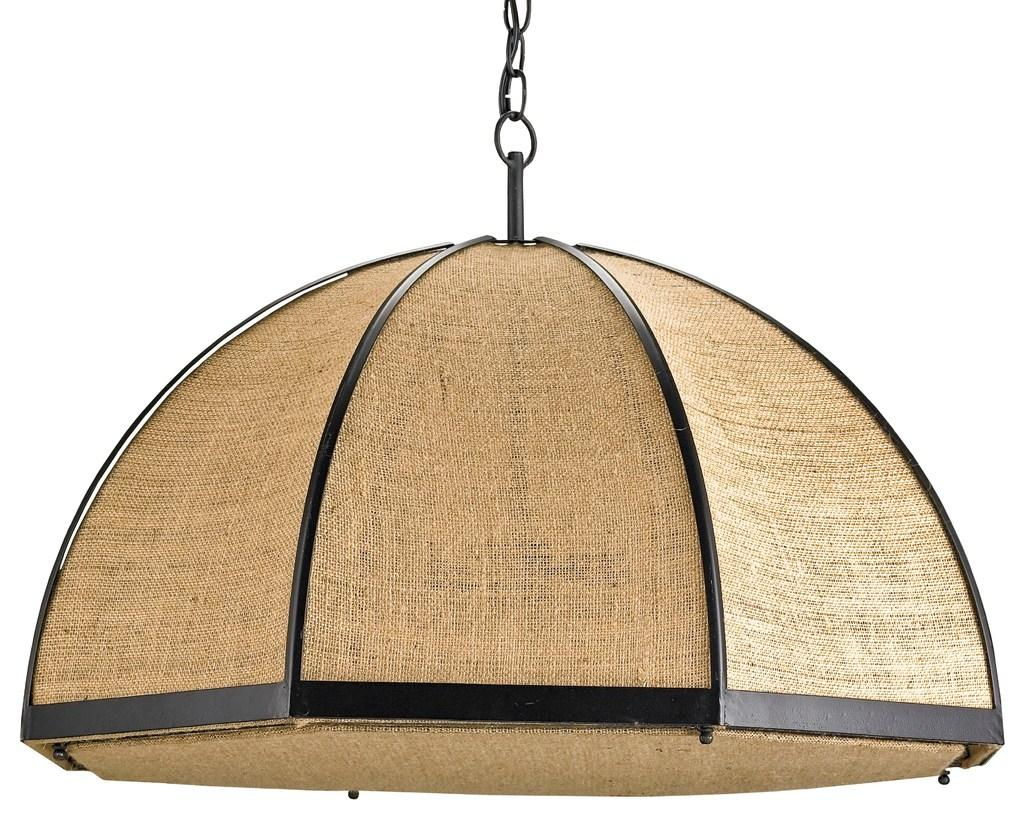What type of lighting fixture is present in the image? There is a chandelier in the image. What color is the background of the image? The background of the image is white. What type of sail can be seen in the image? There is no sail present in the image. What type of bun is visible on the table in the image? There is no bun present in the image. What type of meat is being cooked in the image? There is no meat or cooking activity present in the image. 